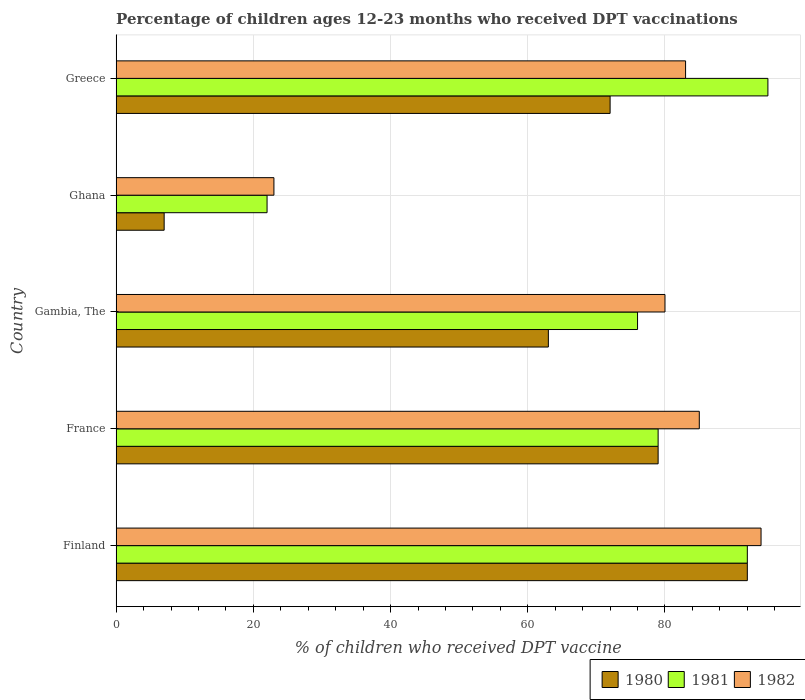How many different coloured bars are there?
Provide a succinct answer. 3. How many groups of bars are there?
Your response must be concise. 5. What is the label of the 3rd group of bars from the top?
Provide a short and direct response. Gambia, The. In how many cases, is the number of bars for a given country not equal to the number of legend labels?
Provide a short and direct response. 0. Across all countries, what is the maximum percentage of children who received DPT vaccination in 1980?
Make the answer very short. 92. What is the total percentage of children who received DPT vaccination in 1981 in the graph?
Offer a terse response. 364. What is the difference between the percentage of children who received DPT vaccination in 1982 in France and that in Ghana?
Give a very brief answer. 62. What is the ratio of the percentage of children who received DPT vaccination in 1980 in Gambia, The to that in Ghana?
Provide a succinct answer. 9. Is the difference between the percentage of children who received DPT vaccination in 1981 in France and Gambia, The greater than the difference between the percentage of children who received DPT vaccination in 1980 in France and Gambia, The?
Your answer should be very brief. No. What is the difference between the highest and the second highest percentage of children who received DPT vaccination in 1982?
Make the answer very short. 9. In how many countries, is the percentage of children who received DPT vaccination in 1980 greater than the average percentage of children who received DPT vaccination in 1980 taken over all countries?
Provide a short and direct response. 4. Is the sum of the percentage of children who received DPT vaccination in 1982 in Finland and France greater than the maximum percentage of children who received DPT vaccination in 1981 across all countries?
Make the answer very short. Yes. Is it the case that in every country, the sum of the percentage of children who received DPT vaccination in 1981 and percentage of children who received DPT vaccination in 1982 is greater than the percentage of children who received DPT vaccination in 1980?
Make the answer very short. Yes. Are the values on the major ticks of X-axis written in scientific E-notation?
Ensure brevity in your answer.  No. Does the graph contain grids?
Make the answer very short. Yes. How many legend labels are there?
Offer a terse response. 3. How are the legend labels stacked?
Keep it short and to the point. Horizontal. What is the title of the graph?
Keep it short and to the point. Percentage of children ages 12-23 months who received DPT vaccinations. Does "1977" appear as one of the legend labels in the graph?
Ensure brevity in your answer.  No. What is the label or title of the X-axis?
Give a very brief answer. % of children who received DPT vaccine. What is the label or title of the Y-axis?
Provide a succinct answer. Country. What is the % of children who received DPT vaccine in 1980 in Finland?
Make the answer very short. 92. What is the % of children who received DPT vaccine of 1981 in Finland?
Provide a short and direct response. 92. What is the % of children who received DPT vaccine of 1982 in Finland?
Provide a short and direct response. 94. What is the % of children who received DPT vaccine of 1980 in France?
Make the answer very short. 79. What is the % of children who received DPT vaccine in 1981 in France?
Offer a very short reply. 79. What is the % of children who received DPT vaccine of 1982 in France?
Give a very brief answer. 85. What is the % of children who received DPT vaccine of 1980 in Gambia, The?
Ensure brevity in your answer.  63. What is the % of children who received DPT vaccine in 1982 in Gambia, The?
Your answer should be compact. 80. What is the % of children who received DPT vaccine of 1980 in Ghana?
Your answer should be compact. 7. What is the % of children who received DPT vaccine in 1981 in Ghana?
Your answer should be compact. 22. What is the % of children who received DPT vaccine in 1980 in Greece?
Offer a terse response. 72. What is the % of children who received DPT vaccine in 1981 in Greece?
Your answer should be very brief. 95. What is the % of children who received DPT vaccine in 1982 in Greece?
Provide a succinct answer. 83. Across all countries, what is the maximum % of children who received DPT vaccine in 1980?
Provide a succinct answer. 92. Across all countries, what is the maximum % of children who received DPT vaccine in 1981?
Offer a very short reply. 95. Across all countries, what is the maximum % of children who received DPT vaccine of 1982?
Offer a very short reply. 94. Across all countries, what is the minimum % of children who received DPT vaccine in 1981?
Provide a succinct answer. 22. What is the total % of children who received DPT vaccine of 1980 in the graph?
Offer a very short reply. 313. What is the total % of children who received DPT vaccine of 1981 in the graph?
Ensure brevity in your answer.  364. What is the total % of children who received DPT vaccine in 1982 in the graph?
Your response must be concise. 365. What is the difference between the % of children who received DPT vaccine of 1980 in Finland and that in France?
Ensure brevity in your answer.  13. What is the difference between the % of children who received DPT vaccine of 1981 in Finland and that in Gambia, The?
Ensure brevity in your answer.  16. What is the difference between the % of children who received DPT vaccine of 1982 in Finland and that in Gambia, The?
Offer a terse response. 14. What is the difference between the % of children who received DPT vaccine of 1980 in Finland and that in Ghana?
Your response must be concise. 85. What is the difference between the % of children who received DPT vaccine of 1981 in Finland and that in Ghana?
Ensure brevity in your answer.  70. What is the difference between the % of children who received DPT vaccine in 1982 in Finland and that in Greece?
Your answer should be very brief. 11. What is the difference between the % of children who received DPT vaccine of 1982 in France and that in Gambia, The?
Make the answer very short. 5. What is the difference between the % of children who received DPT vaccine of 1981 in France and that in Ghana?
Your answer should be compact. 57. What is the difference between the % of children who received DPT vaccine in 1982 in France and that in Ghana?
Offer a very short reply. 62. What is the difference between the % of children who received DPT vaccine in 1981 in France and that in Greece?
Keep it short and to the point. -16. What is the difference between the % of children who received DPT vaccine in 1980 in Gambia, The and that in Ghana?
Ensure brevity in your answer.  56. What is the difference between the % of children who received DPT vaccine in 1981 in Gambia, The and that in Ghana?
Offer a terse response. 54. What is the difference between the % of children who received DPT vaccine in 1982 in Gambia, The and that in Ghana?
Provide a short and direct response. 57. What is the difference between the % of children who received DPT vaccine in 1980 in Gambia, The and that in Greece?
Make the answer very short. -9. What is the difference between the % of children who received DPT vaccine of 1981 in Gambia, The and that in Greece?
Ensure brevity in your answer.  -19. What is the difference between the % of children who received DPT vaccine of 1982 in Gambia, The and that in Greece?
Offer a terse response. -3. What is the difference between the % of children who received DPT vaccine in 1980 in Ghana and that in Greece?
Ensure brevity in your answer.  -65. What is the difference between the % of children who received DPT vaccine of 1981 in Ghana and that in Greece?
Ensure brevity in your answer.  -73. What is the difference between the % of children who received DPT vaccine in 1982 in Ghana and that in Greece?
Keep it short and to the point. -60. What is the difference between the % of children who received DPT vaccine of 1980 in Finland and the % of children who received DPT vaccine of 1981 in France?
Keep it short and to the point. 13. What is the difference between the % of children who received DPT vaccine in 1981 in Finland and the % of children who received DPT vaccine in 1982 in France?
Make the answer very short. 7. What is the difference between the % of children who received DPT vaccine of 1980 in Finland and the % of children who received DPT vaccine of 1981 in Gambia, The?
Your answer should be compact. 16. What is the difference between the % of children who received DPT vaccine in 1980 in Finland and the % of children who received DPT vaccine in 1981 in Ghana?
Give a very brief answer. 70. What is the difference between the % of children who received DPT vaccine of 1980 in Finland and the % of children who received DPT vaccine of 1982 in Ghana?
Your answer should be compact. 69. What is the difference between the % of children who received DPT vaccine of 1980 in Finland and the % of children who received DPT vaccine of 1981 in Greece?
Offer a very short reply. -3. What is the difference between the % of children who received DPT vaccine in 1980 in Finland and the % of children who received DPT vaccine in 1982 in Greece?
Offer a very short reply. 9. What is the difference between the % of children who received DPT vaccine of 1981 in Finland and the % of children who received DPT vaccine of 1982 in Greece?
Offer a very short reply. 9. What is the difference between the % of children who received DPT vaccine of 1980 in France and the % of children who received DPT vaccine of 1981 in Gambia, The?
Offer a terse response. 3. What is the difference between the % of children who received DPT vaccine of 1980 in France and the % of children who received DPT vaccine of 1982 in Gambia, The?
Your answer should be compact. -1. What is the difference between the % of children who received DPT vaccine in 1981 in France and the % of children who received DPT vaccine in 1982 in Gambia, The?
Ensure brevity in your answer.  -1. What is the difference between the % of children who received DPT vaccine of 1980 in France and the % of children who received DPT vaccine of 1981 in Ghana?
Make the answer very short. 57. What is the difference between the % of children who received DPT vaccine of 1981 in France and the % of children who received DPT vaccine of 1982 in Ghana?
Keep it short and to the point. 56. What is the difference between the % of children who received DPT vaccine of 1980 in France and the % of children who received DPT vaccine of 1981 in Greece?
Keep it short and to the point. -16. What is the difference between the % of children who received DPT vaccine of 1981 in France and the % of children who received DPT vaccine of 1982 in Greece?
Your answer should be compact. -4. What is the difference between the % of children who received DPT vaccine of 1980 in Gambia, The and the % of children who received DPT vaccine of 1982 in Ghana?
Offer a very short reply. 40. What is the difference between the % of children who received DPT vaccine of 1980 in Gambia, The and the % of children who received DPT vaccine of 1981 in Greece?
Provide a short and direct response. -32. What is the difference between the % of children who received DPT vaccine in 1980 in Gambia, The and the % of children who received DPT vaccine in 1982 in Greece?
Ensure brevity in your answer.  -20. What is the difference between the % of children who received DPT vaccine of 1980 in Ghana and the % of children who received DPT vaccine of 1981 in Greece?
Your response must be concise. -88. What is the difference between the % of children who received DPT vaccine in 1980 in Ghana and the % of children who received DPT vaccine in 1982 in Greece?
Make the answer very short. -76. What is the difference between the % of children who received DPT vaccine of 1981 in Ghana and the % of children who received DPT vaccine of 1982 in Greece?
Provide a succinct answer. -61. What is the average % of children who received DPT vaccine in 1980 per country?
Offer a very short reply. 62.6. What is the average % of children who received DPT vaccine in 1981 per country?
Offer a terse response. 72.8. What is the average % of children who received DPT vaccine of 1982 per country?
Make the answer very short. 73. What is the difference between the % of children who received DPT vaccine of 1980 and % of children who received DPT vaccine of 1981 in Finland?
Give a very brief answer. 0. What is the difference between the % of children who received DPT vaccine of 1980 and % of children who received DPT vaccine of 1982 in Finland?
Your answer should be very brief. -2. What is the difference between the % of children who received DPT vaccine in 1981 and % of children who received DPT vaccine in 1982 in Finland?
Give a very brief answer. -2. What is the difference between the % of children who received DPT vaccine in 1980 and % of children who received DPT vaccine in 1982 in France?
Offer a terse response. -6. What is the difference between the % of children who received DPT vaccine of 1980 and % of children who received DPT vaccine of 1981 in Gambia, The?
Your answer should be very brief. -13. What is the difference between the % of children who received DPT vaccine of 1980 and % of children who received DPT vaccine of 1982 in Gambia, The?
Give a very brief answer. -17. What is the difference between the % of children who received DPT vaccine of 1981 and % of children who received DPT vaccine of 1982 in Gambia, The?
Make the answer very short. -4. What is the difference between the % of children who received DPT vaccine in 1980 and % of children who received DPT vaccine in 1982 in Ghana?
Keep it short and to the point. -16. What is the difference between the % of children who received DPT vaccine of 1981 and % of children who received DPT vaccine of 1982 in Ghana?
Your answer should be compact. -1. What is the difference between the % of children who received DPT vaccine in 1980 and % of children who received DPT vaccine in 1981 in Greece?
Ensure brevity in your answer.  -23. What is the difference between the % of children who received DPT vaccine of 1981 and % of children who received DPT vaccine of 1982 in Greece?
Make the answer very short. 12. What is the ratio of the % of children who received DPT vaccine of 1980 in Finland to that in France?
Your response must be concise. 1.16. What is the ratio of the % of children who received DPT vaccine of 1981 in Finland to that in France?
Provide a succinct answer. 1.16. What is the ratio of the % of children who received DPT vaccine in 1982 in Finland to that in France?
Provide a succinct answer. 1.11. What is the ratio of the % of children who received DPT vaccine in 1980 in Finland to that in Gambia, The?
Make the answer very short. 1.46. What is the ratio of the % of children who received DPT vaccine of 1981 in Finland to that in Gambia, The?
Offer a terse response. 1.21. What is the ratio of the % of children who received DPT vaccine in 1982 in Finland to that in Gambia, The?
Give a very brief answer. 1.18. What is the ratio of the % of children who received DPT vaccine in 1980 in Finland to that in Ghana?
Your response must be concise. 13.14. What is the ratio of the % of children who received DPT vaccine of 1981 in Finland to that in Ghana?
Provide a short and direct response. 4.18. What is the ratio of the % of children who received DPT vaccine of 1982 in Finland to that in Ghana?
Give a very brief answer. 4.09. What is the ratio of the % of children who received DPT vaccine in 1980 in Finland to that in Greece?
Keep it short and to the point. 1.28. What is the ratio of the % of children who received DPT vaccine of 1981 in Finland to that in Greece?
Ensure brevity in your answer.  0.97. What is the ratio of the % of children who received DPT vaccine of 1982 in Finland to that in Greece?
Your answer should be very brief. 1.13. What is the ratio of the % of children who received DPT vaccine of 1980 in France to that in Gambia, The?
Provide a short and direct response. 1.25. What is the ratio of the % of children who received DPT vaccine of 1981 in France to that in Gambia, The?
Your answer should be very brief. 1.04. What is the ratio of the % of children who received DPT vaccine in 1980 in France to that in Ghana?
Offer a terse response. 11.29. What is the ratio of the % of children who received DPT vaccine in 1981 in France to that in Ghana?
Offer a terse response. 3.59. What is the ratio of the % of children who received DPT vaccine in 1982 in France to that in Ghana?
Keep it short and to the point. 3.7. What is the ratio of the % of children who received DPT vaccine in 1980 in France to that in Greece?
Offer a very short reply. 1.1. What is the ratio of the % of children who received DPT vaccine in 1981 in France to that in Greece?
Keep it short and to the point. 0.83. What is the ratio of the % of children who received DPT vaccine in 1982 in France to that in Greece?
Provide a short and direct response. 1.02. What is the ratio of the % of children who received DPT vaccine in 1980 in Gambia, The to that in Ghana?
Keep it short and to the point. 9. What is the ratio of the % of children who received DPT vaccine in 1981 in Gambia, The to that in Ghana?
Your response must be concise. 3.45. What is the ratio of the % of children who received DPT vaccine in 1982 in Gambia, The to that in Ghana?
Provide a succinct answer. 3.48. What is the ratio of the % of children who received DPT vaccine in 1981 in Gambia, The to that in Greece?
Provide a short and direct response. 0.8. What is the ratio of the % of children who received DPT vaccine of 1982 in Gambia, The to that in Greece?
Your answer should be compact. 0.96. What is the ratio of the % of children who received DPT vaccine of 1980 in Ghana to that in Greece?
Ensure brevity in your answer.  0.1. What is the ratio of the % of children who received DPT vaccine of 1981 in Ghana to that in Greece?
Your answer should be very brief. 0.23. What is the ratio of the % of children who received DPT vaccine in 1982 in Ghana to that in Greece?
Your response must be concise. 0.28. What is the difference between the highest and the second highest % of children who received DPT vaccine of 1980?
Your answer should be very brief. 13. What is the difference between the highest and the lowest % of children who received DPT vaccine in 1981?
Ensure brevity in your answer.  73. What is the difference between the highest and the lowest % of children who received DPT vaccine in 1982?
Your answer should be very brief. 71. 